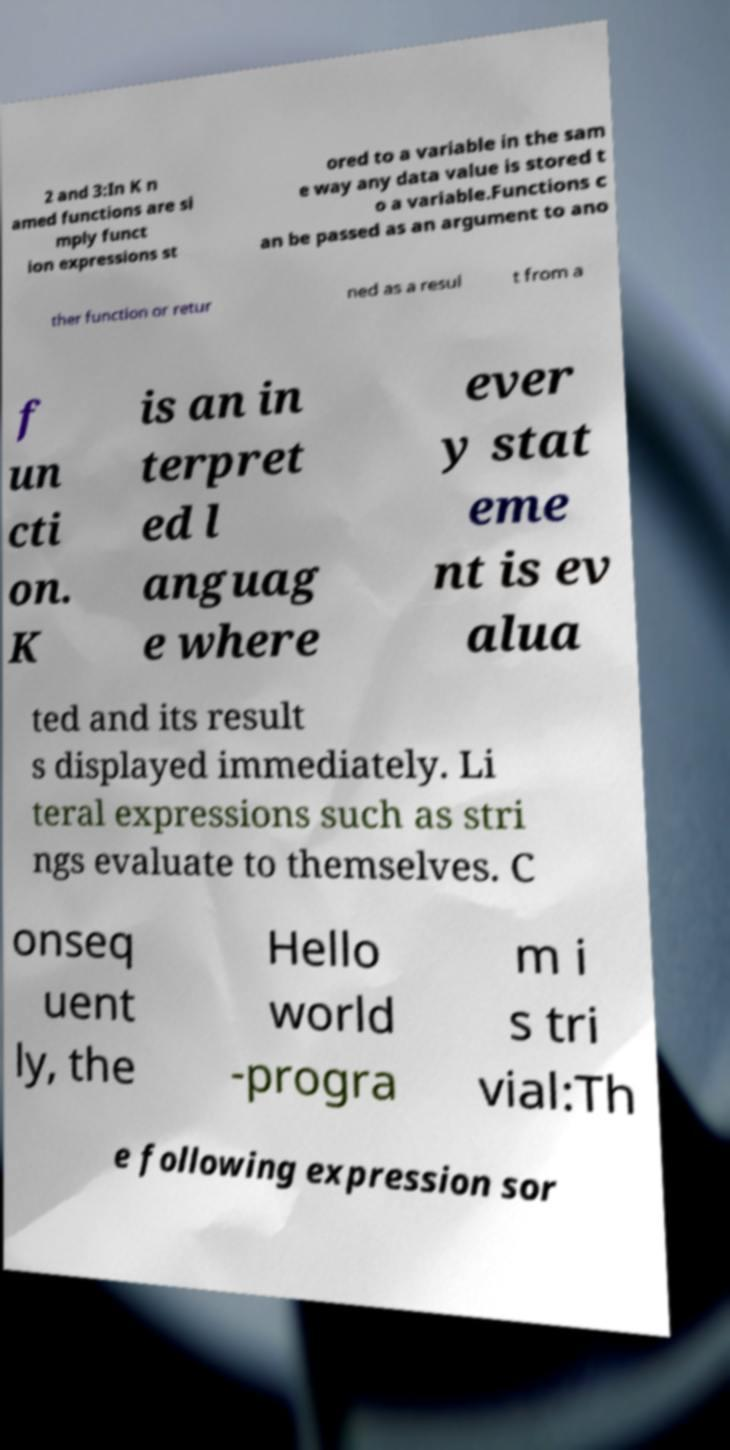What messages or text are displayed in this image? I need them in a readable, typed format. 2 and 3:In K n amed functions are si mply funct ion expressions st ored to a variable in the sam e way any data value is stored t o a variable.Functions c an be passed as an argument to ano ther function or retur ned as a resul t from a f un cti on. K is an in terpret ed l anguag e where ever y stat eme nt is ev alua ted and its result s displayed immediately. Li teral expressions such as stri ngs evaluate to themselves. C onseq uent ly, the Hello world -progra m i s tri vial:Th e following expression sor 